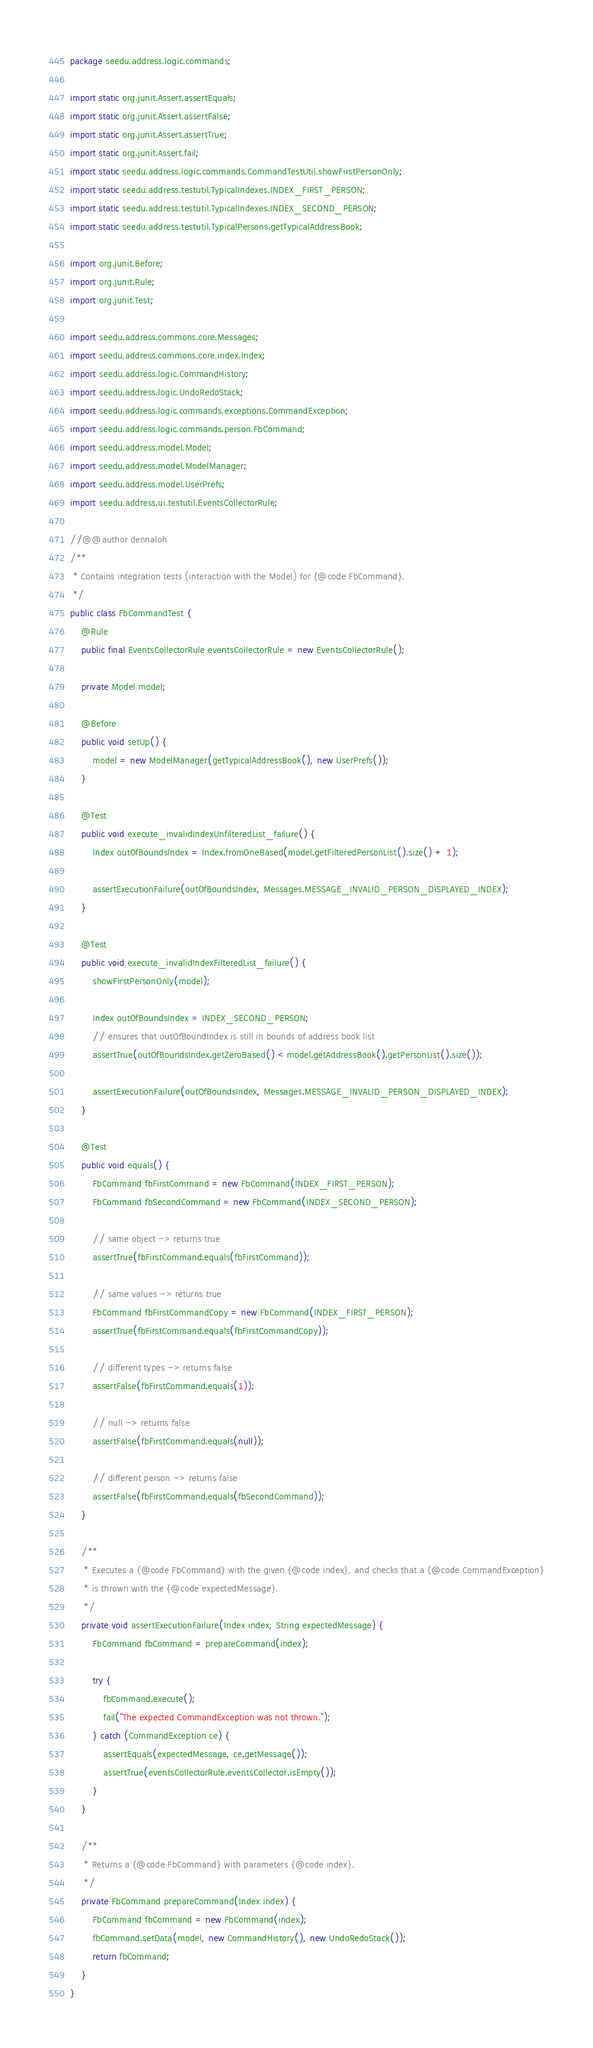Convert code to text. <code><loc_0><loc_0><loc_500><loc_500><_Java_>package seedu.address.logic.commands;

import static org.junit.Assert.assertEquals;
import static org.junit.Assert.assertFalse;
import static org.junit.Assert.assertTrue;
import static org.junit.Assert.fail;
import static seedu.address.logic.commands.CommandTestUtil.showFirstPersonOnly;
import static seedu.address.testutil.TypicalIndexes.INDEX_FIRST_PERSON;
import static seedu.address.testutil.TypicalIndexes.INDEX_SECOND_PERSON;
import static seedu.address.testutil.TypicalPersons.getTypicalAddressBook;

import org.junit.Before;
import org.junit.Rule;
import org.junit.Test;

import seedu.address.commons.core.Messages;
import seedu.address.commons.core.index.Index;
import seedu.address.logic.CommandHistory;
import seedu.address.logic.UndoRedoStack;
import seedu.address.logic.commands.exceptions.CommandException;
import seedu.address.logic.commands.person.FbCommand;
import seedu.address.model.Model;
import seedu.address.model.ModelManager;
import seedu.address.model.UserPrefs;
import seedu.address.ui.testutil.EventsCollectorRule;

//@@author dennaloh
/**
 * Contains integration tests (interaction with the Model) for {@code FbCommand}.
 */
public class FbCommandTest {
    @Rule
    public final EventsCollectorRule eventsCollectorRule = new EventsCollectorRule();

    private Model model;

    @Before
    public void setUp() {
        model = new ModelManager(getTypicalAddressBook(), new UserPrefs());
    }

    @Test
    public void execute_invalidIndexUnfilteredList_failure() {
        Index outOfBoundsIndex = Index.fromOneBased(model.getFilteredPersonList().size() + 1);

        assertExecutionFailure(outOfBoundsIndex, Messages.MESSAGE_INVALID_PERSON_DISPLAYED_INDEX);
    }

    @Test
    public void execute_invalidIndexFilteredList_failure() {
        showFirstPersonOnly(model);

        Index outOfBoundsIndex = INDEX_SECOND_PERSON;
        // ensures that outOfBoundIndex is still in bounds of address book list
        assertTrue(outOfBoundsIndex.getZeroBased() < model.getAddressBook().getPersonList().size());

        assertExecutionFailure(outOfBoundsIndex, Messages.MESSAGE_INVALID_PERSON_DISPLAYED_INDEX);
    }

    @Test
    public void equals() {
        FbCommand fbFirstCommand = new FbCommand(INDEX_FIRST_PERSON);
        FbCommand fbSecondCommand = new FbCommand(INDEX_SECOND_PERSON);

        // same object -> returns true
        assertTrue(fbFirstCommand.equals(fbFirstCommand));

        // same values -> returns true
        FbCommand fbFirstCommandCopy = new FbCommand(INDEX_FIRST_PERSON);
        assertTrue(fbFirstCommand.equals(fbFirstCommandCopy));

        // different types -> returns false
        assertFalse(fbFirstCommand.equals(1));

        // null -> returns false
        assertFalse(fbFirstCommand.equals(null));

        // different person -> returns false
        assertFalse(fbFirstCommand.equals(fbSecondCommand));
    }

    /**
     * Executes a {@code FbCommand} with the given {@code index}, and checks that a {@code CommandException}
     * is thrown with the {@code expectedMessage}.
     */
    private void assertExecutionFailure(Index index, String expectedMessage) {
        FbCommand fbCommand = prepareCommand(index);

        try {
            fbCommand.execute();
            fail("The expected CommandException was not thrown.");
        } catch (CommandException ce) {
            assertEquals(expectedMessage, ce.getMessage());
            assertTrue(eventsCollectorRule.eventsCollector.isEmpty());
        }
    }

    /**
     * Returns a {@code FbCommand} with parameters {@code index}.
     */
    private FbCommand prepareCommand(Index index) {
        FbCommand fbCommand = new FbCommand(index);
        fbCommand.setData(model, new CommandHistory(), new UndoRedoStack());
        return fbCommand;
    }
}
</code> 